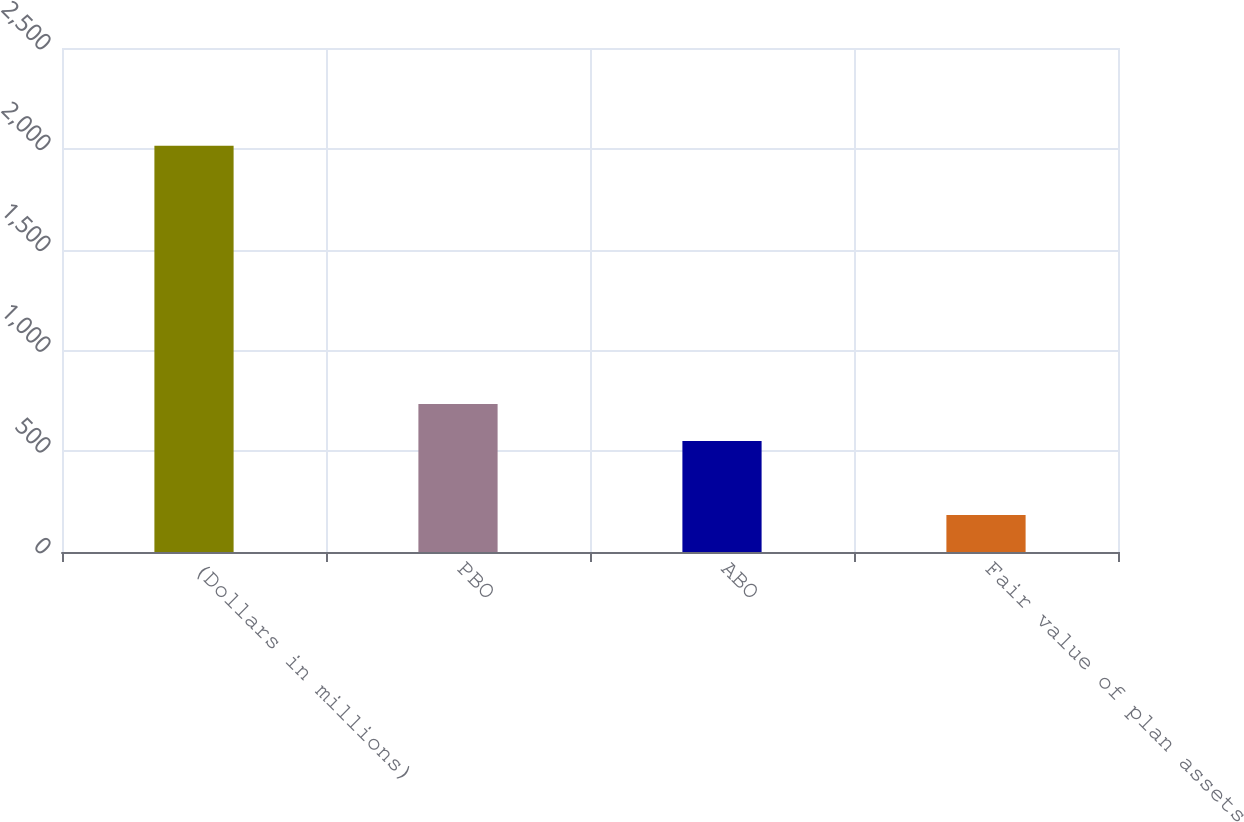Convert chart. <chart><loc_0><loc_0><loc_500><loc_500><bar_chart><fcel>(Dollars in millions)<fcel>PBO<fcel>ABO<fcel>Fair value of plan assets<nl><fcel>2015<fcel>734.2<fcel>551<fcel>183<nl></chart> 